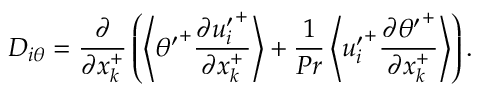Convert formula to latex. <formula><loc_0><loc_0><loc_500><loc_500>D _ { i \theta } = \frac { \partial } { \partial x _ { k } ^ { + } } \left ( \left < { \theta ^ { \prime } } ^ { + } \frac { \partial { u _ { i } ^ { \prime } } ^ { + } } { \partial x _ { k } ^ { + } } \right > + \frac { 1 } { P r } \left < { u _ { i } ^ { \prime } } ^ { + } \frac { \partial { \theta ^ { \prime } } ^ { + } } { \partial x _ { k } ^ { + } } \right > \right ) .</formula> 